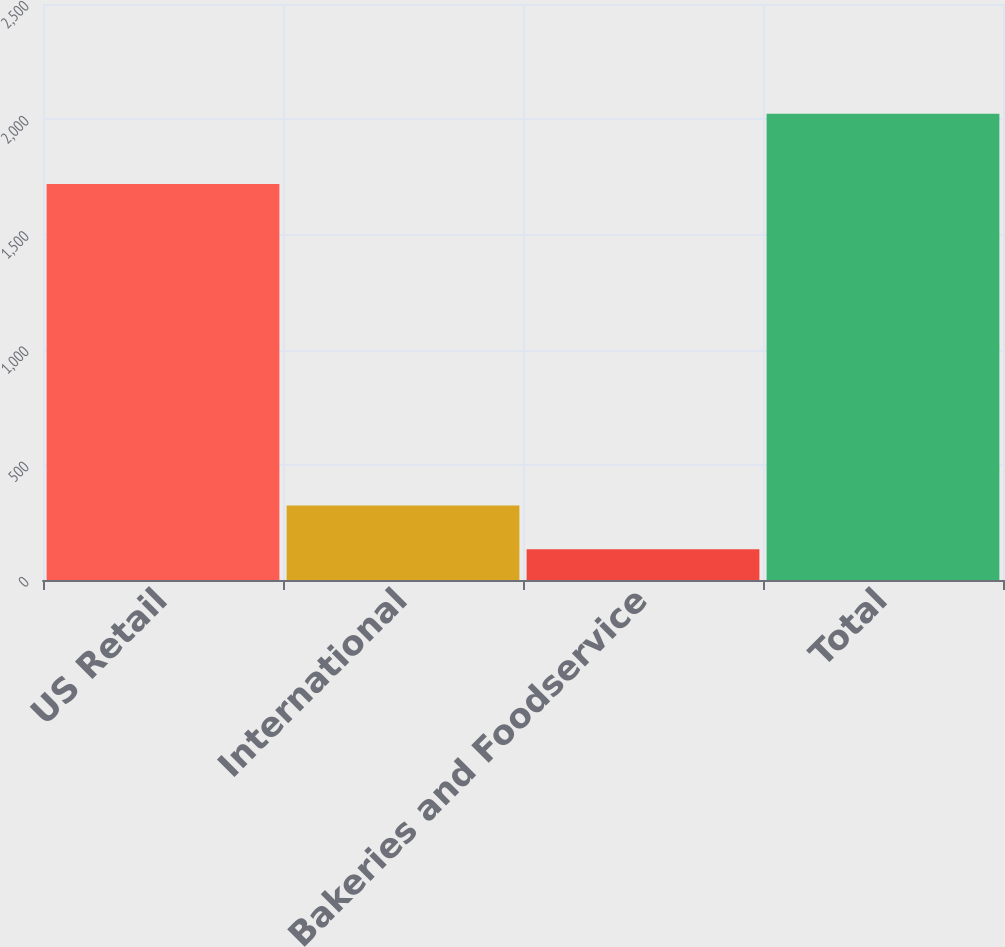<chart> <loc_0><loc_0><loc_500><loc_500><bar_chart><fcel>US Retail<fcel>International<fcel>Bakeries and Foodservice<fcel>Total<nl><fcel>1719<fcel>323<fcel>134<fcel>2024<nl></chart> 